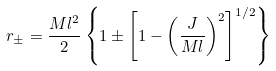<formula> <loc_0><loc_0><loc_500><loc_500>r _ { \pm } = { \frac { M l ^ { 2 } } { 2 } } \left \{ 1 \pm \left [ 1 - \left ( { \frac { J } { M l } } \right ) ^ { 2 } \right ] ^ { 1 / 2 } \right \}</formula> 